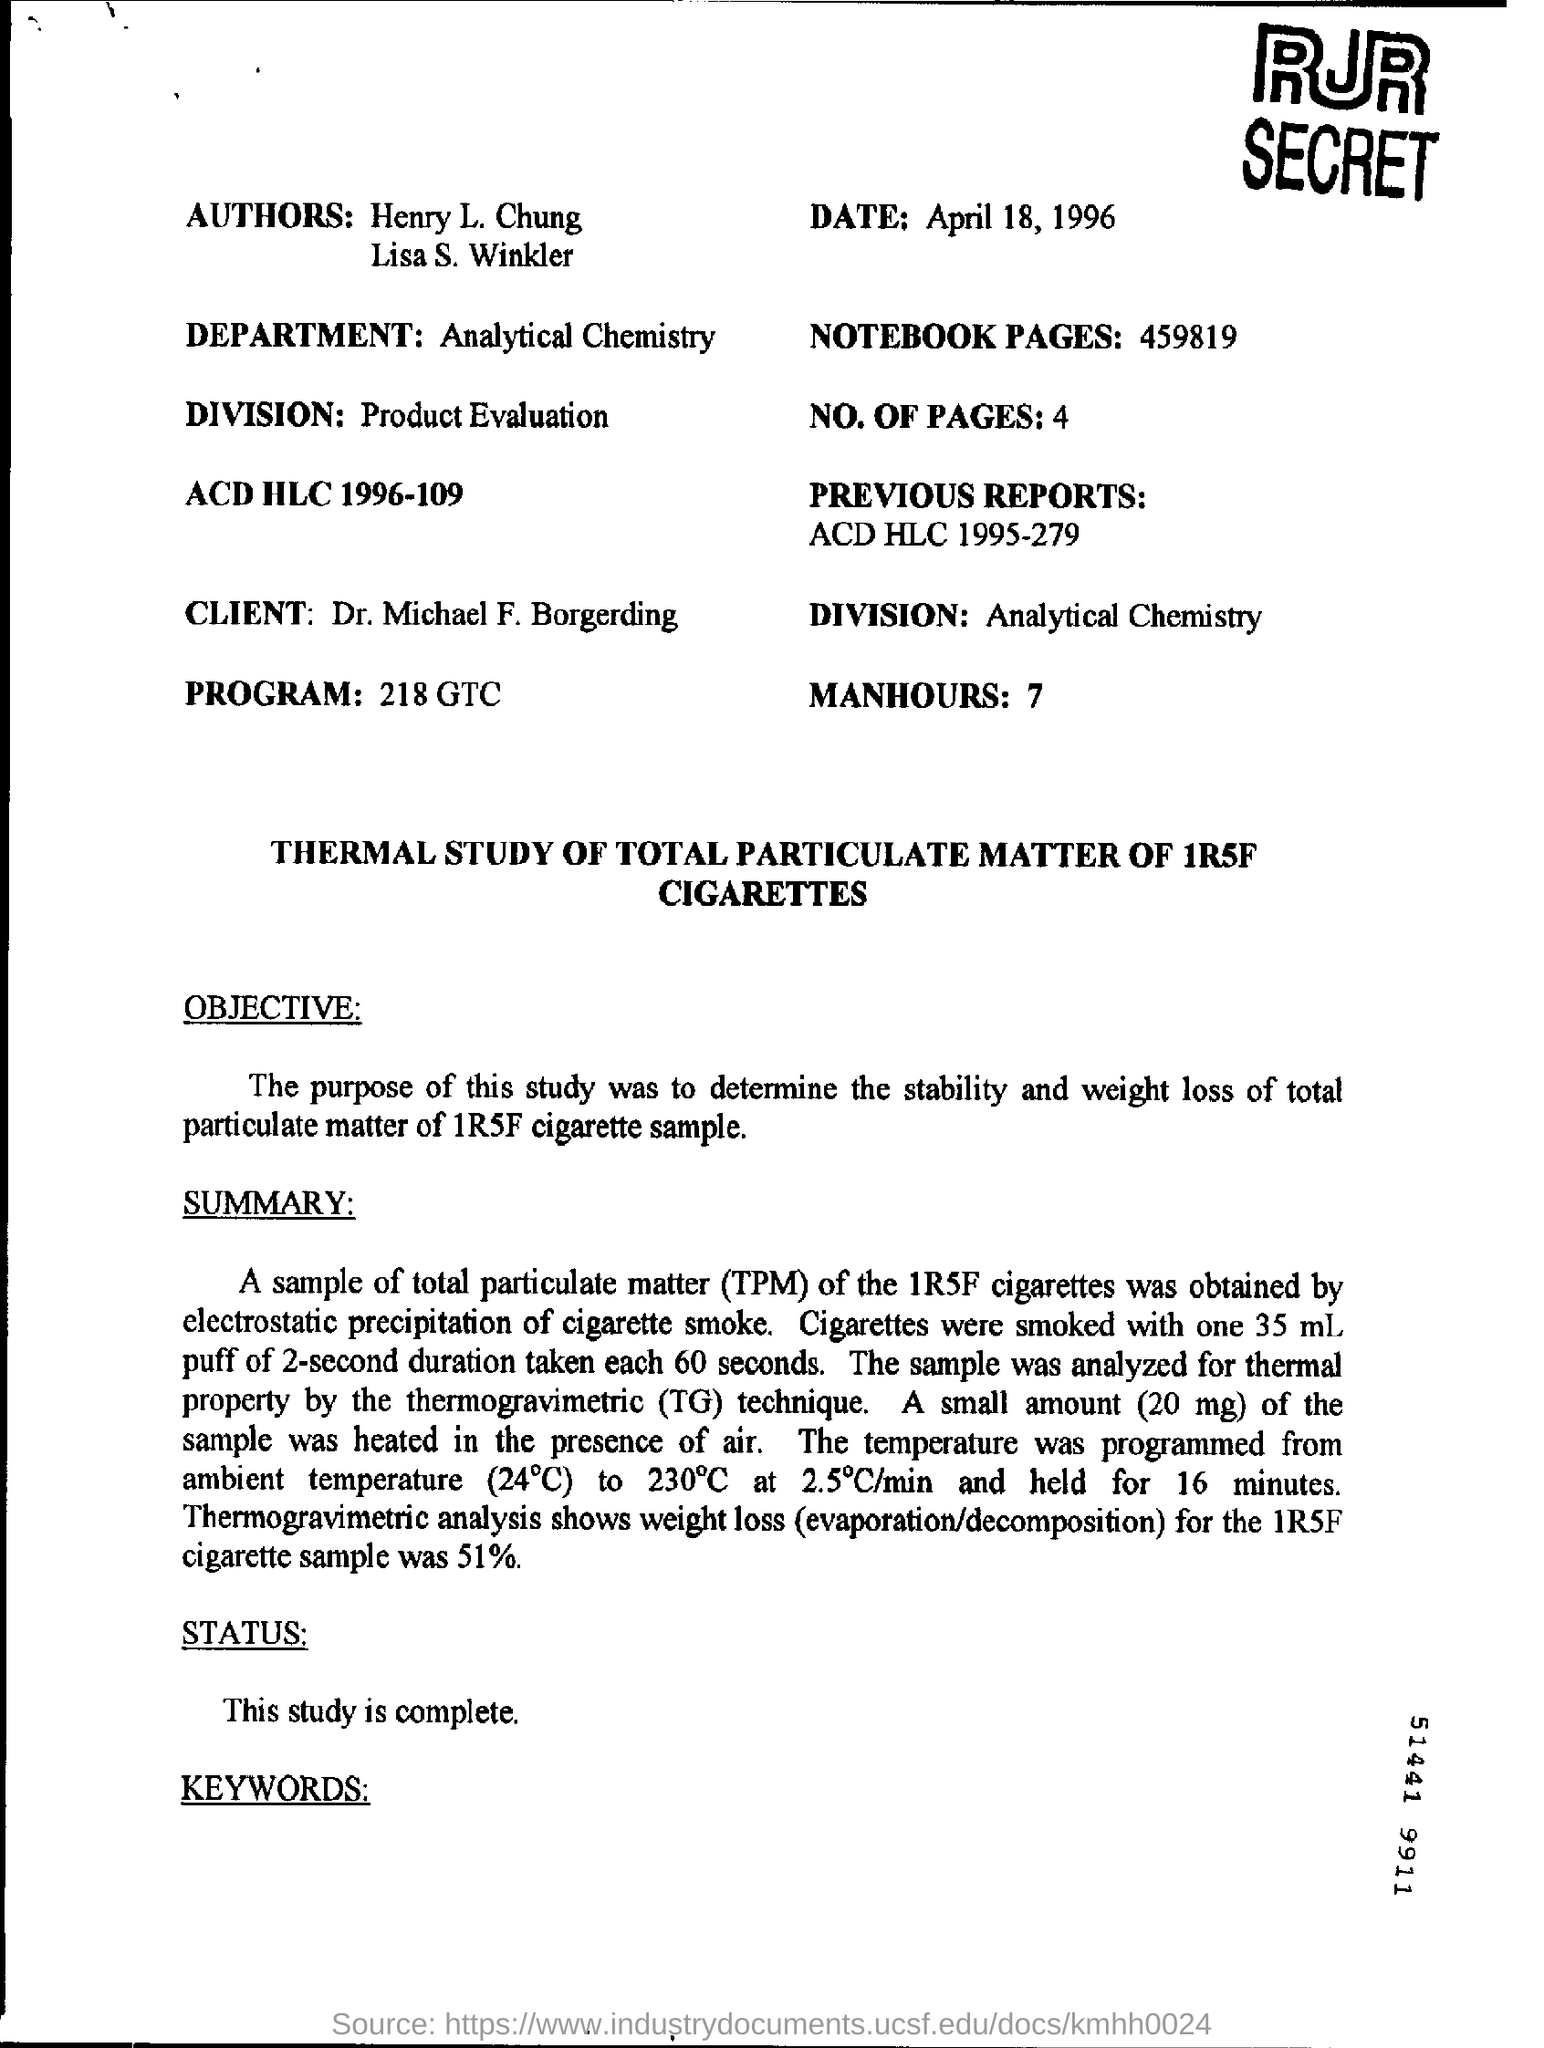Who are the authors
Keep it short and to the point. Henry l. chung     lisa s. winkler. What is the date given?
Your answer should be very brief. April 18 , 1996. How many notebook pages are there?
Your answer should be compact. 459819. Which department is mentioned?
Ensure brevity in your answer.  Analytical chemistry. Who is the client?
Provide a succinct answer. Dr. Michael F. Borgerding. How much manhours is mentioned?
Offer a very short reply. 7. What does TPM stand for?
Your answer should be compact. Total particulate matter. Which technique was used to analyze the sample for thermal property?
Offer a very short reply. Thermogravimetric (tg) technique. What is the status of the study?
Your answer should be compact. This study is complete. 